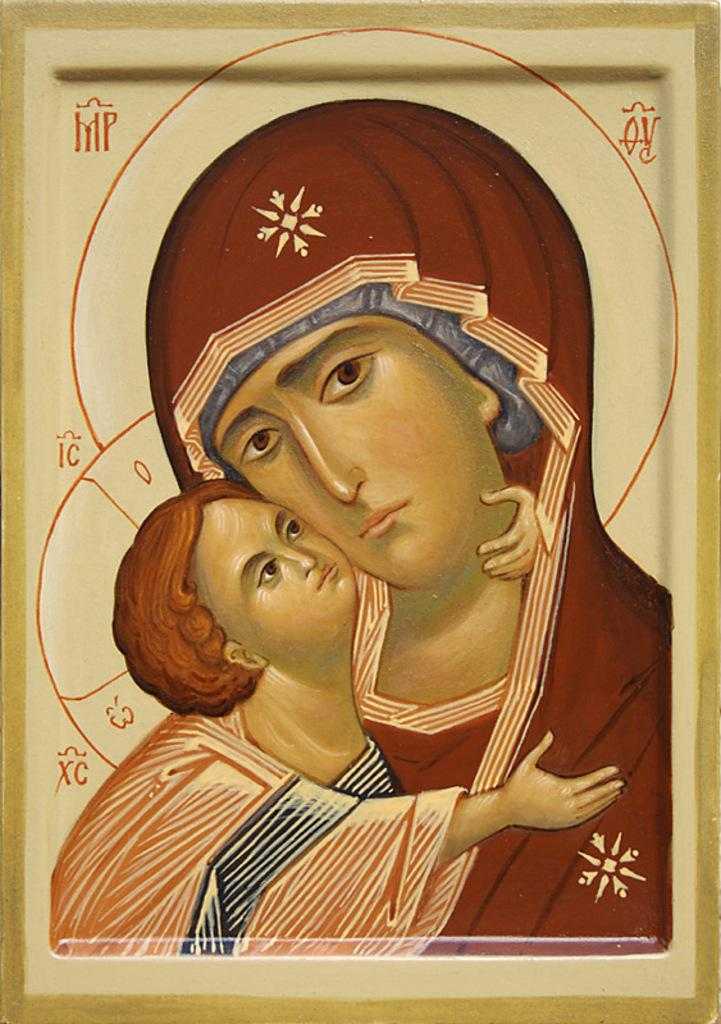What is featured in the image? There is a poster in the image. What is shown on the poster? The poster depicts a woman holding a baby. What type of lettuce is the cat eating in the image? There is no lettuce or cat present in the image; it only features a poster with a woman holding a baby. 